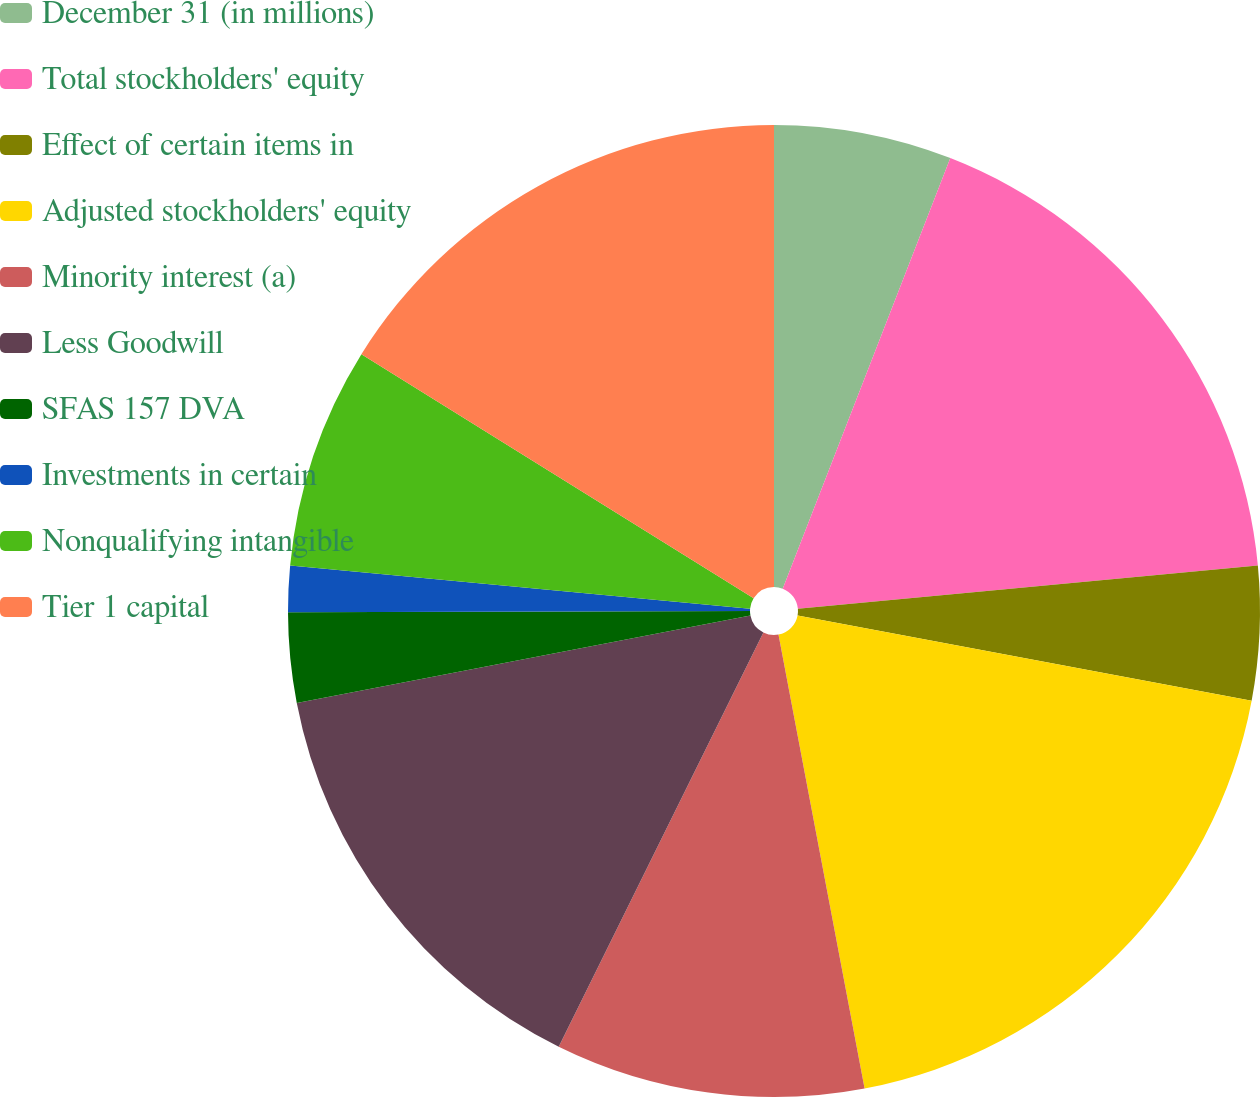Convert chart to OTSL. <chart><loc_0><loc_0><loc_500><loc_500><pie_chart><fcel>December 31 (in millions)<fcel>Total stockholders' equity<fcel>Effect of certain items in<fcel>Adjusted stockholders' equity<fcel>Minority interest (a)<fcel>Less Goodwill<fcel>SFAS 157 DVA<fcel>Investments in certain<fcel>Nonqualifying intangible<fcel>Tier 1 capital<nl><fcel>5.91%<fcel>17.6%<fcel>4.45%<fcel>19.06%<fcel>10.29%<fcel>14.67%<fcel>2.99%<fcel>1.53%<fcel>7.37%<fcel>16.14%<nl></chart> 